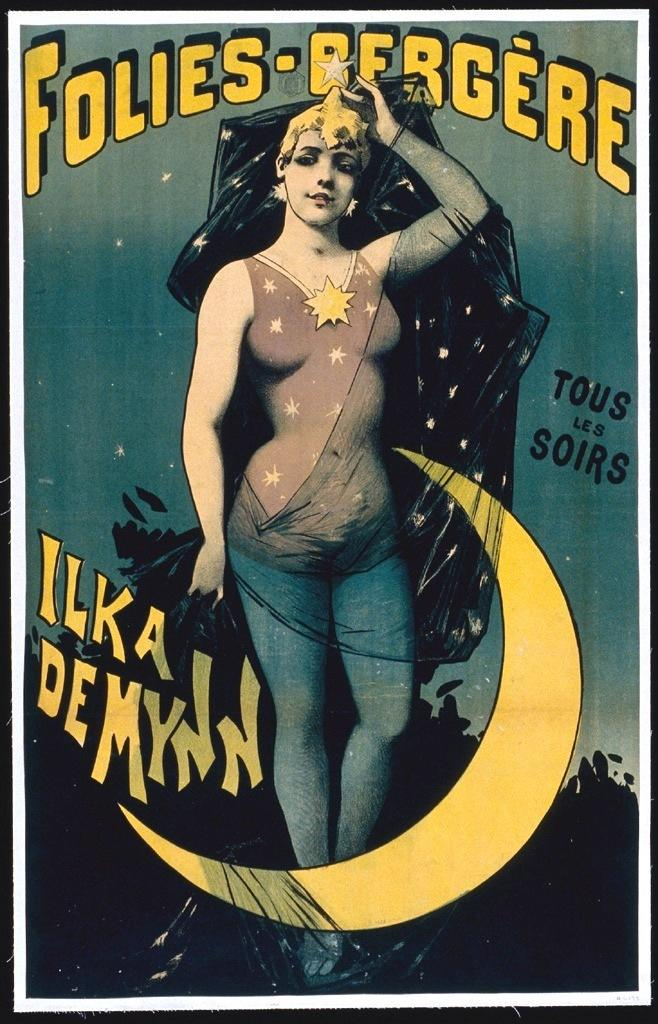What type of visual is the image? The image is a poster. What elements are present on the poster? The poster contains texts, paintings of a woman, paintings of the sky, and paintings of other objects. How many people are in the crowd depicted in the poster? There is no crowd depicted in the poster; it features paintings of a woman, the sky, and other objects. 